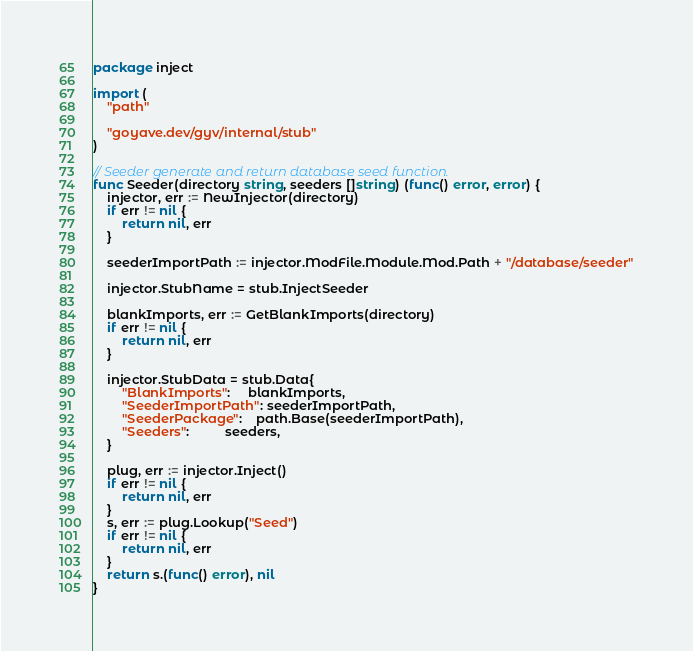<code> <loc_0><loc_0><loc_500><loc_500><_Go_>package inject

import (
	"path"

	"goyave.dev/gyv/internal/stub"
)

// Seeder generate and return database seed function.
func Seeder(directory string, seeders []string) (func() error, error) {
	injector, err := NewInjector(directory)
	if err != nil {
		return nil, err
	}

	seederImportPath := injector.ModFile.Module.Mod.Path + "/database/seeder"

	injector.StubName = stub.InjectSeeder

	blankImports, err := GetBlankImports(directory)
	if err != nil {
		return nil, err
	}

	injector.StubData = stub.Data{
		"BlankImports":     blankImports,
		"SeederImportPath": seederImportPath,
		"SeederPackage":    path.Base(seederImportPath),
		"Seeders":          seeders,
	}

	plug, err := injector.Inject()
	if err != nil {
		return nil, err
	}
	s, err := plug.Lookup("Seed")
	if err != nil {
		return nil, err
	}
	return s.(func() error), nil
}
</code> 